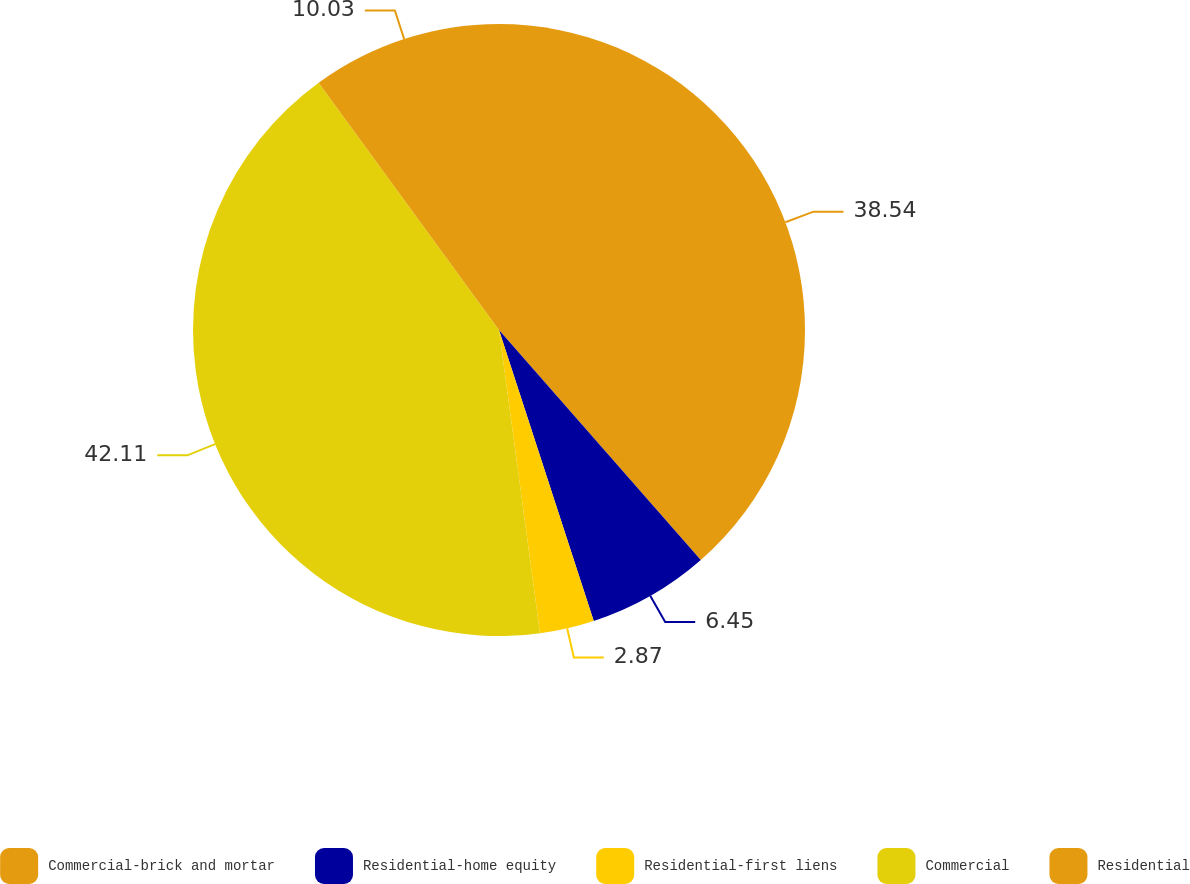Convert chart to OTSL. <chart><loc_0><loc_0><loc_500><loc_500><pie_chart><fcel>Commercial-brick and mortar<fcel>Residential-home equity<fcel>Residential-first liens<fcel>Commercial<fcel>Residential<nl><fcel>38.54%<fcel>6.45%<fcel>2.87%<fcel>42.11%<fcel>10.03%<nl></chart> 